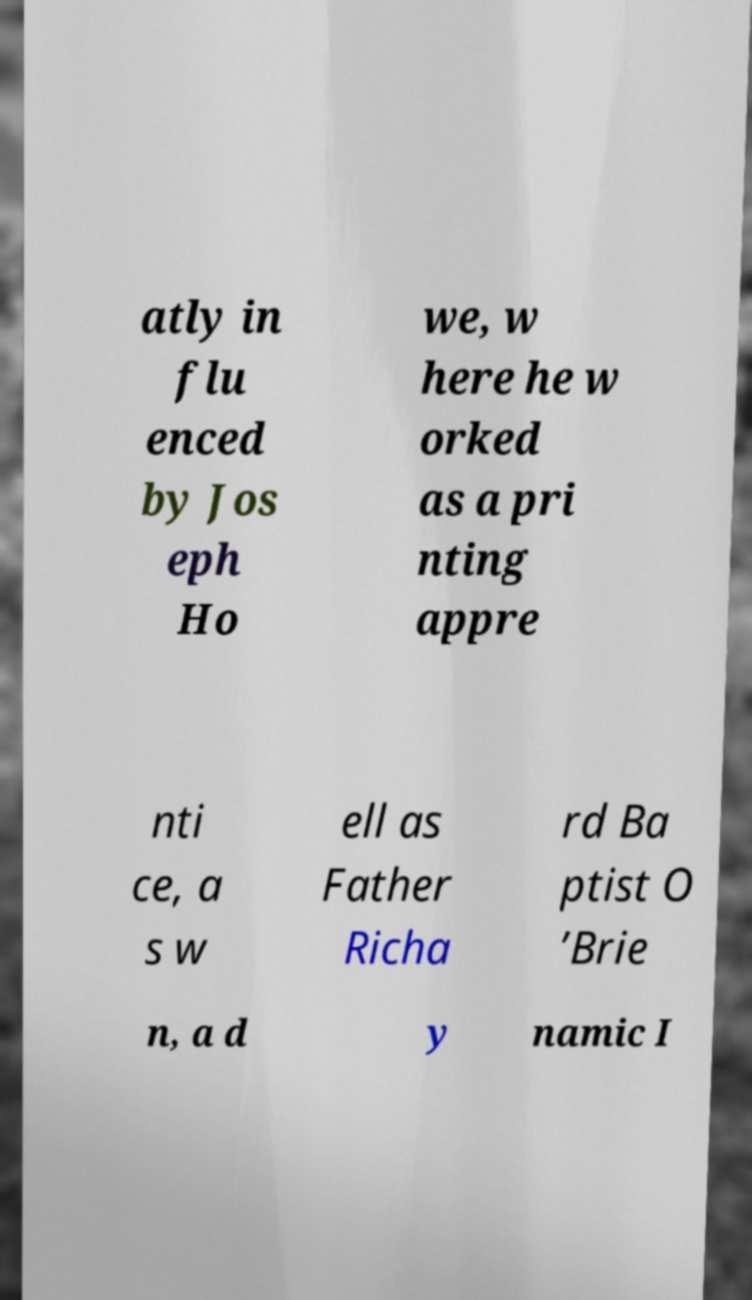Please read and relay the text visible in this image. What does it say? atly in flu enced by Jos eph Ho we, w here he w orked as a pri nting appre nti ce, a s w ell as Father Richa rd Ba ptist O ’Brie n, a d y namic I 